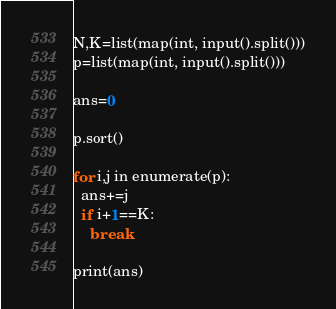<code> <loc_0><loc_0><loc_500><loc_500><_Python_>N,K=list(map(int, input().split()))
p=list(map(int, input().split()))

ans=0

p.sort()

for i,j in enumerate(p):
  ans+=j
  if i+1==K:
    break
    
print(ans)</code> 